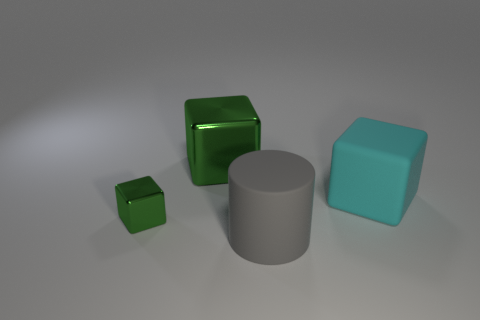Subtract all metal cubes. How many cubes are left? 1 Subtract 3 cubes. How many cubes are left? 0 Add 1 large red metallic cylinders. How many objects exist? 5 Subtract all cyan cubes. How many cubes are left? 2 Subtract all cylinders. How many objects are left? 3 Subtract all purple cylinders. How many green blocks are left? 2 Add 4 big green blocks. How many big green blocks exist? 5 Subtract 1 gray cylinders. How many objects are left? 3 Subtract all blue cylinders. Subtract all brown spheres. How many cylinders are left? 1 Subtract all metallic cubes. Subtract all big rubber cylinders. How many objects are left? 1 